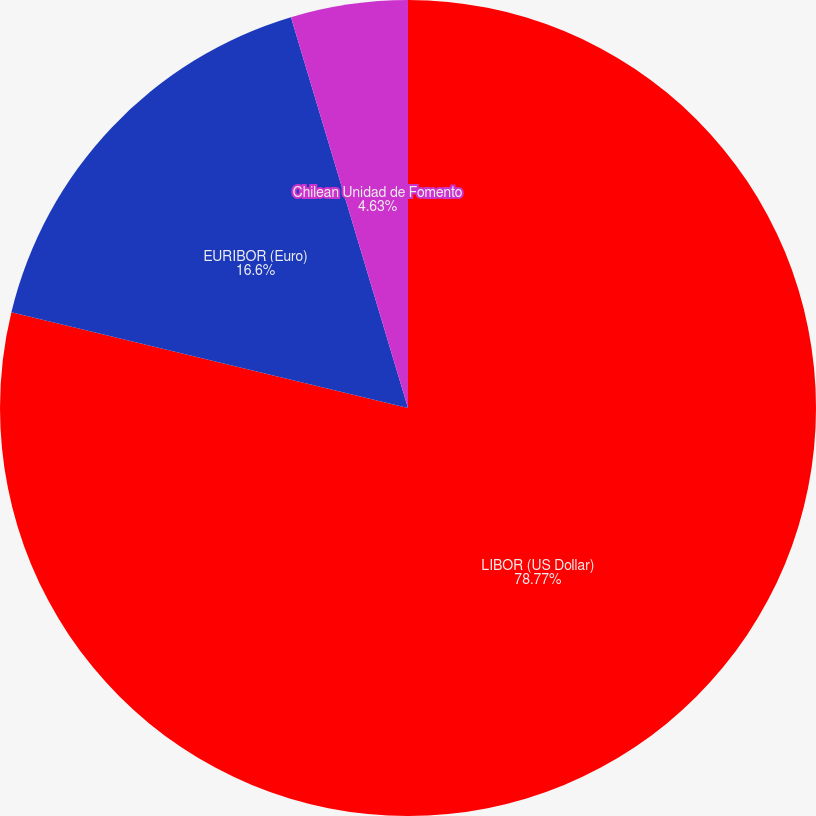<chart> <loc_0><loc_0><loc_500><loc_500><pie_chart><fcel>LIBOR (US Dollar)<fcel>EURIBOR (Euro)<fcel>Chilean Unidad de Fomento<nl><fcel>78.77%<fcel>16.6%<fcel>4.63%<nl></chart> 